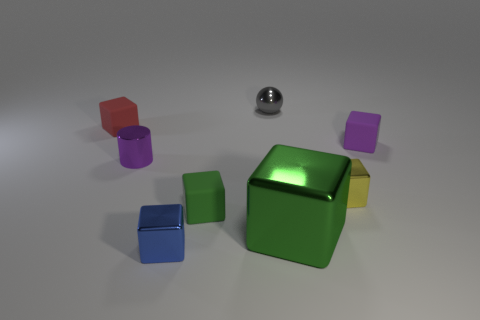Can you tell me which colors are present in the objects displayed? Certainly! The objects exhibit a variety of colors. Starting from the left, we have a red cube, a purple cube, a green cube, a metallic sphere that reflects the environment, another blue cube, and a small yellow cube at the front. 